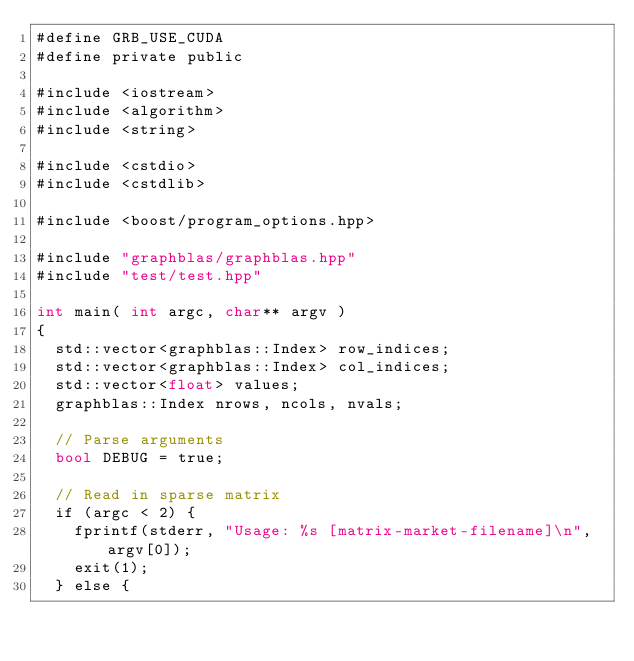<code> <loc_0><loc_0><loc_500><loc_500><_Cuda_>#define GRB_USE_CUDA
#define private public

#include <iostream>
#include <algorithm>
#include <string>

#include <cstdio>
#include <cstdlib>

#include <boost/program_options.hpp>

#include "graphblas/graphblas.hpp"
#include "test/test.hpp"

int main( int argc, char** argv )
{
  std::vector<graphblas::Index> row_indices;
  std::vector<graphblas::Index> col_indices;
  std::vector<float> values;
  graphblas::Index nrows, ncols, nvals;

  // Parse arguments
  bool DEBUG = true;

  // Read in sparse matrix
  if (argc < 2) {
    fprintf(stderr, "Usage: %s [matrix-market-filename]\n", argv[0]);
    exit(1);
  } else { </code> 